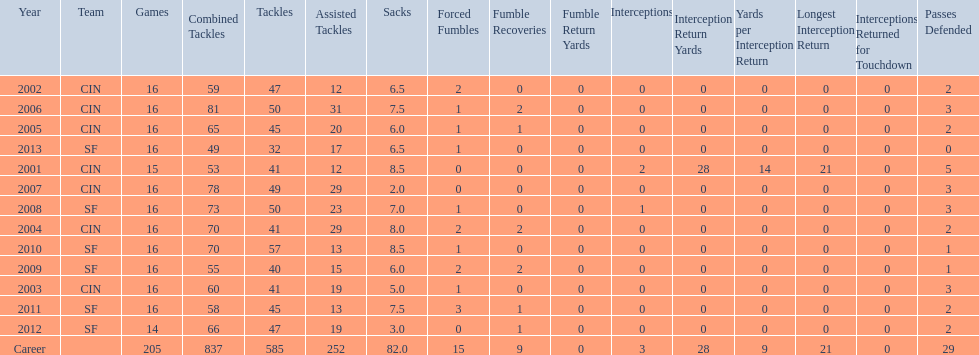What is the entire count of sacks made by smith? 82.0. 